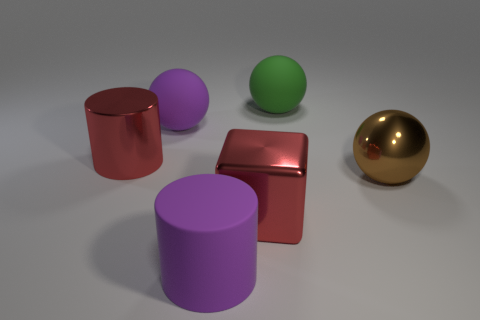What materials do these objects seem to be made of? The objects in the image appear to be computer-generated with simulated materials. The cylinders and the sphere on the left have a matte finish suggestive of plastic, while the sphere on the right has a shiny, reflective surface that resembles metal. Can you describe the lighting in the scene? The lighting in the image is soft and diffused, with shadows indicating a light source above the objects, slightly offset to the right. The gentle shadows and subtle reflections on the objects contribute to a calm and even tone in the scene. 